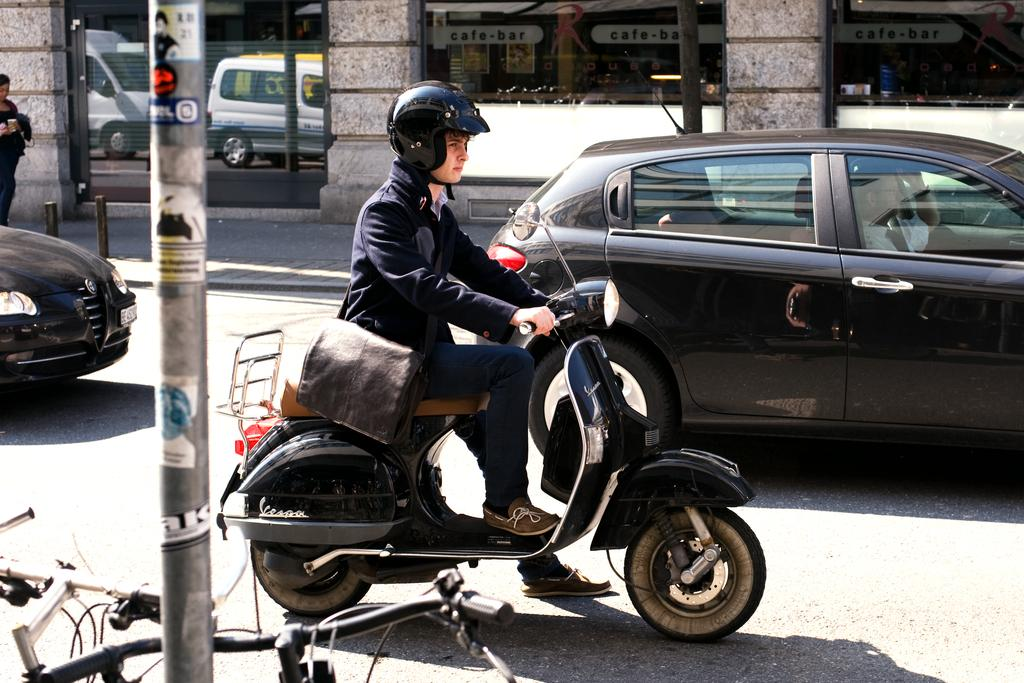What is the man in the image doing? The man is riding a scooter in the image. What can be seen in the background of the image? There are vehicles, a building, a glass door, a person, bicycles, and a pole in the background. How many types of transportation are visible in the image? There are at least two types of transportation visible: a scooter and bicycles. What type of silk is being used to cover the stove in the image? There is no stove or silk present in the image. What color is the underwear of the person in the background? We cannot determine the color of the underwear of the person in the background, as it is not visible in the image. 